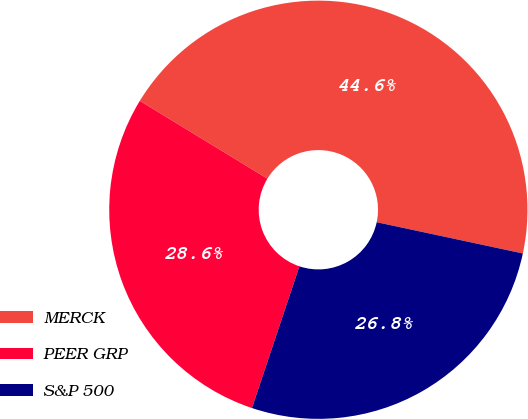<chart> <loc_0><loc_0><loc_500><loc_500><pie_chart><fcel>MERCK<fcel>PEER GRP<fcel>S&P 500<nl><fcel>44.64%<fcel>28.57%<fcel>26.79%<nl></chart> 